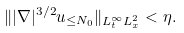<formula> <loc_0><loc_0><loc_500><loc_500>\| | \nabla | ^ { 3 / 2 } u _ { \leq N _ { 0 } } \| _ { L _ { t } ^ { \infty } L _ { x } ^ { 2 } } < \eta .</formula> 